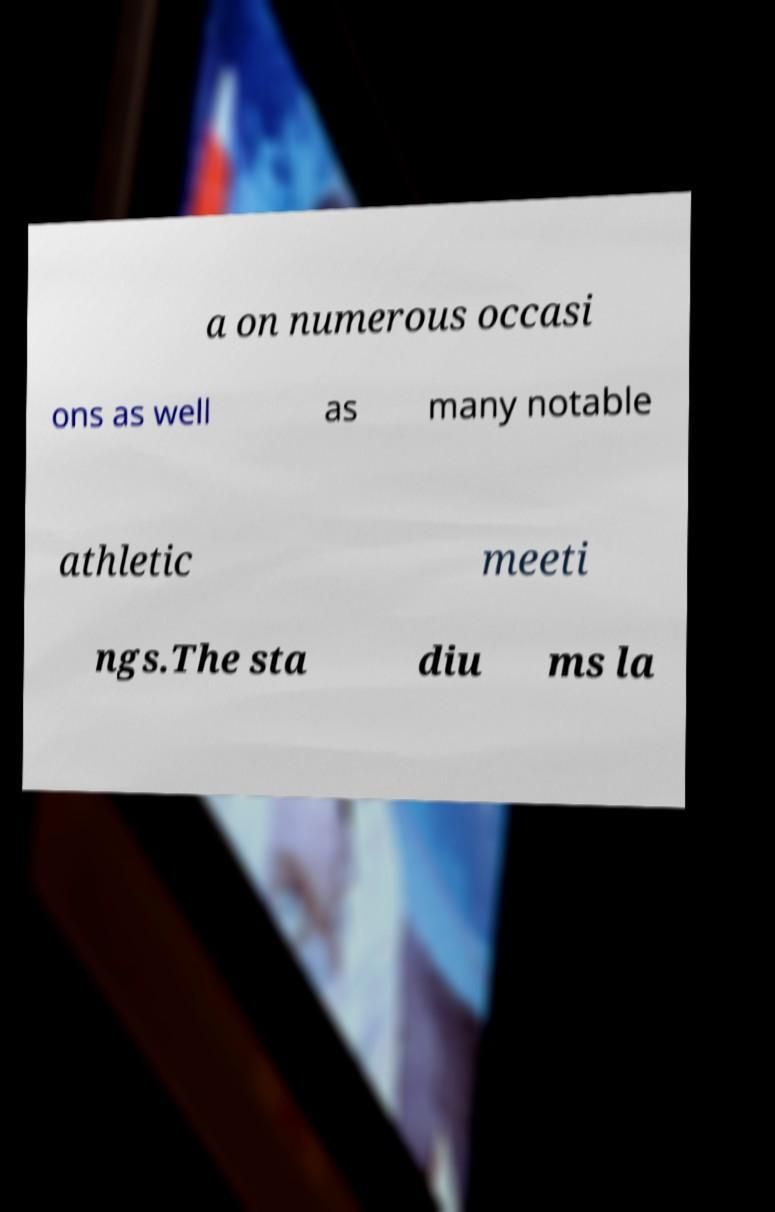Can you read and provide the text displayed in the image?This photo seems to have some interesting text. Can you extract and type it out for me? a on numerous occasi ons as well as many notable athletic meeti ngs.The sta diu ms la 